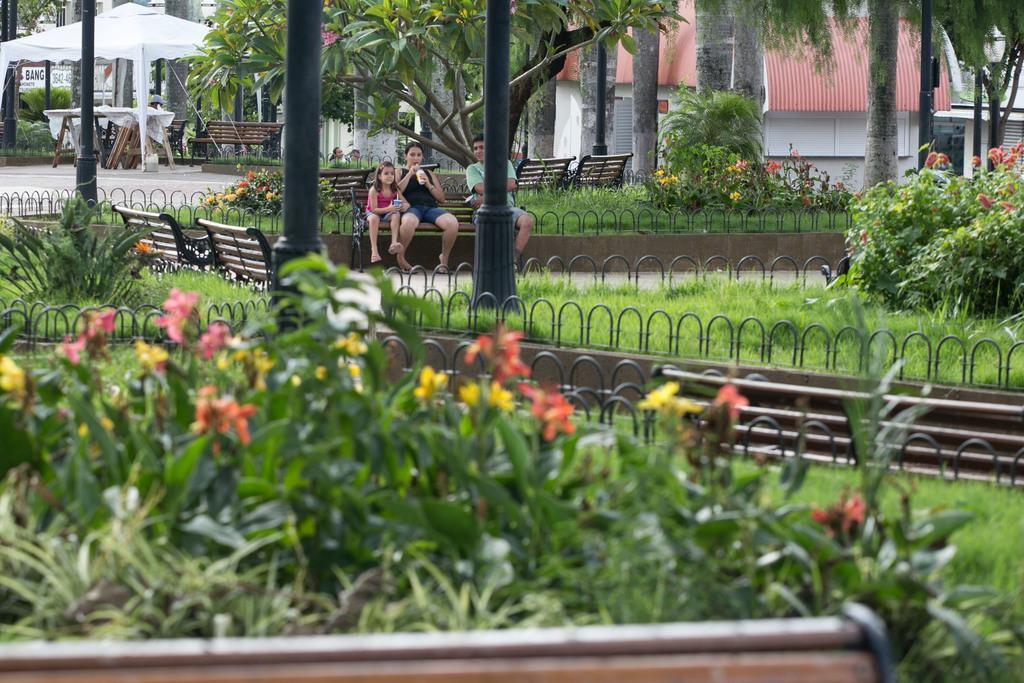Please provide a concise description of this image. A man,a woman and a girl are sitting on a bench in a garden. There are some trees,plants and benches in the surrounding. There is a tent in white color under which some benches are arranged. 